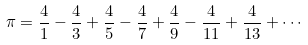<formula> <loc_0><loc_0><loc_500><loc_500>\pi = { \frac { 4 } { 1 } } - { \frac { 4 } { 3 } } + { \frac { 4 } { 5 } } - { \frac { 4 } { 7 } } + { \frac { 4 } { 9 } } - { \frac { 4 } { 1 1 } } + { \frac { 4 } { 1 3 } } + \cdots</formula> 